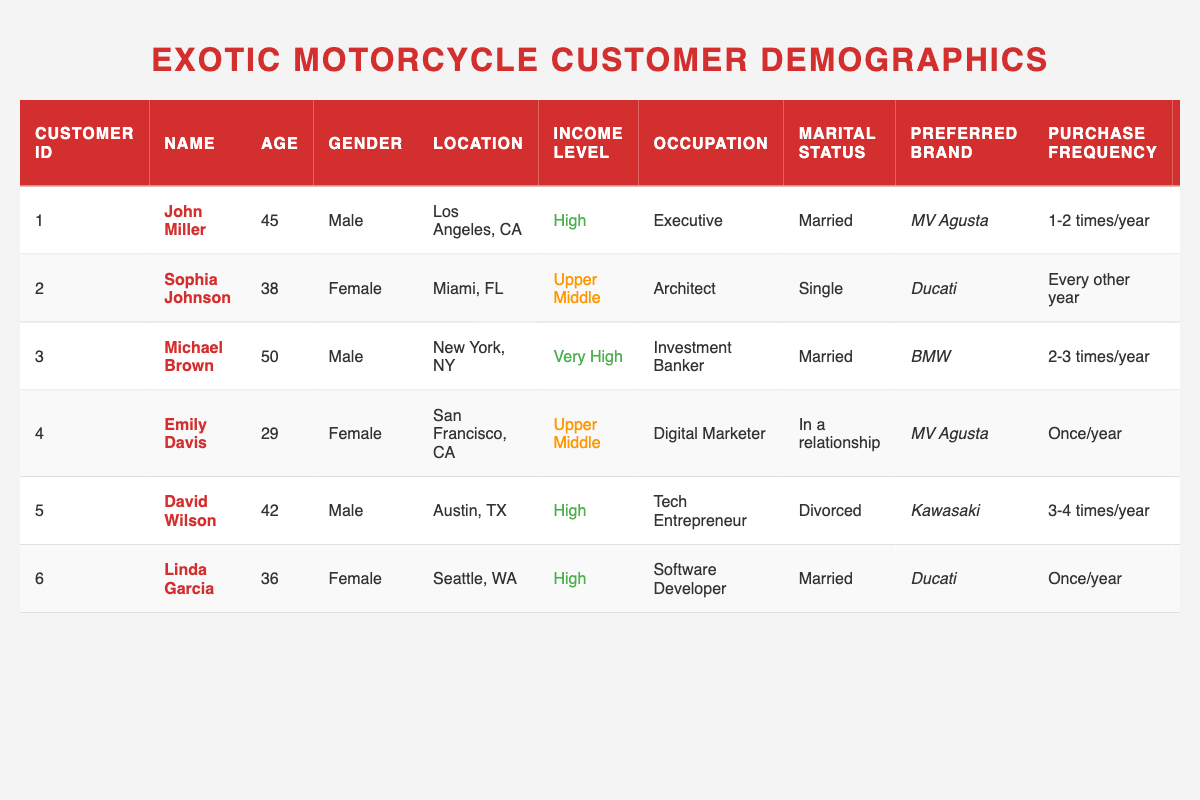What is the preferred brand of John Miller? According to the table, John Miller's preferred brand is MV Agusta.
Answer: MV Agusta How many customers have a high income level? There are three customers with a high income level: John Miller, David Wilson, and Michael Brown.
Answer: 3 Which customer has the highest average spend per purchase? By comparing the average spend per purchase of all customers, Michael Brown has the highest at $30,000.
Answer: Michael Brown What is the average age of customers purchasing Ducati motorcycles? The customers preferring Ducati are Sophia Johnson, Michael Brown, and Linda Garcia, with ages of 38, 50, and 36 respectively. The average is (38 + 50 + 36)/3 = 41.33, rounding gives 41.
Answer: 41 Do all customers have a preferred model listed? Yes, all customers have listed their preferred model in the table.
Answer: Yes Which customer has the premium dealership experience? From the table, John Miller is noted to have a premium dealership experience.
Answer: John Miller What is the total average spend for customers who prefer MV Agusta? The customers preferring MV Agusta are John Miller, Emily Davis, and Linda Garcia, with spends of $25,000, $23,000, and $22,000 respectively. Summing gives $70,000 of which the average is $70,000/3 = $23,333.33, rounding gives $23,333.
Answer: $23,333 How many customers purchase motorcycles 3-4 times a year? The table shows that David Wilson purchases motorcycles 3-4 times a year. He is the only customer listed in this frequency.
Answer: 1 What percentage of customers are male? There are 3 male customers (John Miller, Michael Brown, and David Wilson) out of 6 total customers, which is (3/6)*100 = 50%.
Answer: 50% Is there a customer who prefers a secondary brand of Triumph? Looking at the data, Emily Davis lists Triumph as her secondary brand.
Answer: Yes 